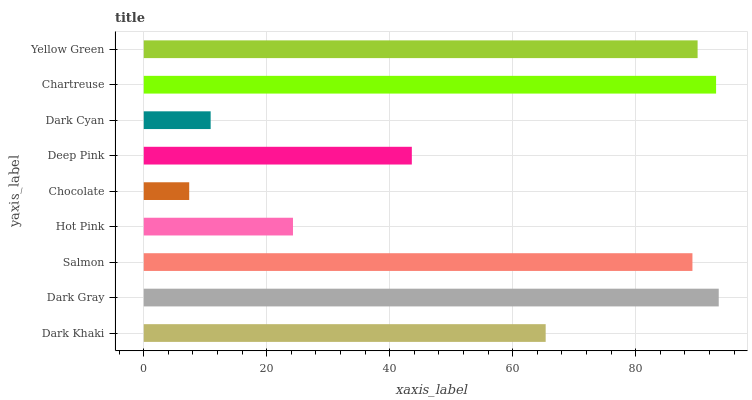Is Chocolate the minimum?
Answer yes or no. Yes. Is Dark Gray the maximum?
Answer yes or no. Yes. Is Salmon the minimum?
Answer yes or no. No. Is Salmon the maximum?
Answer yes or no. No. Is Dark Gray greater than Salmon?
Answer yes or no. Yes. Is Salmon less than Dark Gray?
Answer yes or no. Yes. Is Salmon greater than Dark Gray?
Answer yes or no. No. Is Dark Gray less than Salmon?
Answer yes or no. No. Is Dark Khaki the high median?
Answer yes or no. Yes. Is Dark Khaki the low median?
Answer yes or no. Yes. Is Dark Gray the high median?
Answer yes or no. No. Is Salmon the low median?
Answer yes or no. No. 